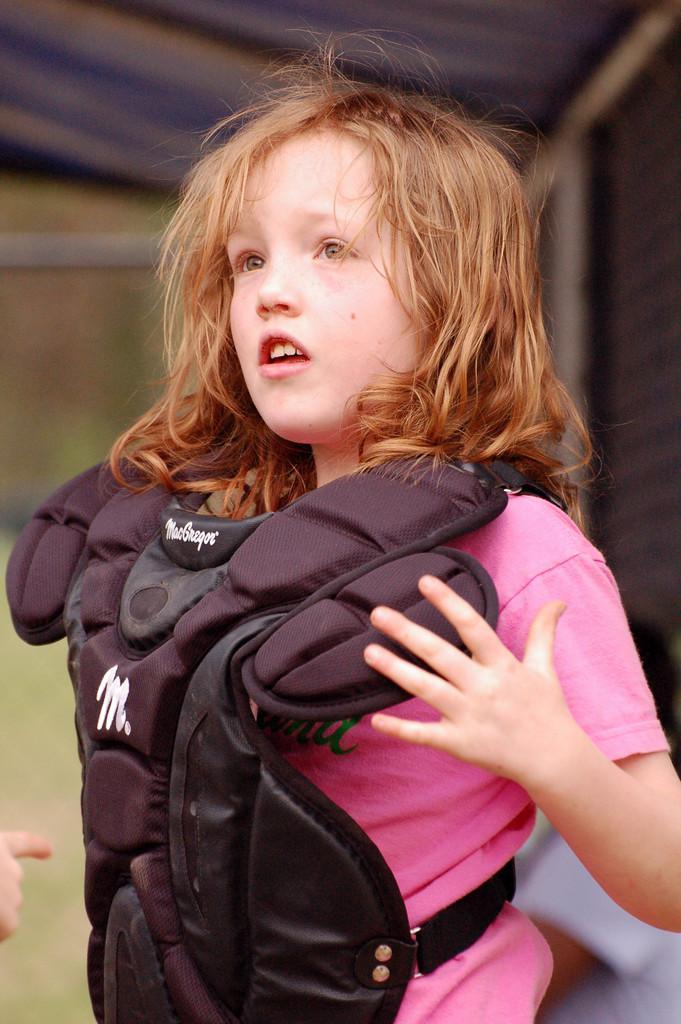Can you describe this image briefly? This picture shows a girl standing. She wore a jacket and we see a woman seated on the side. The jacket is black in color and girl wore pink color t-shirt. 